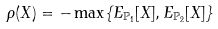Convert formula to latex. <formula><loc_0><loc_0><loc_500><loc_500>\rho ( X ) = - \max \{ E _ { \mathbb { P } _ { 1 } } [ X ] , E _ { \mathbb { P } _ { 2 } } [ X ] \}</formula> 